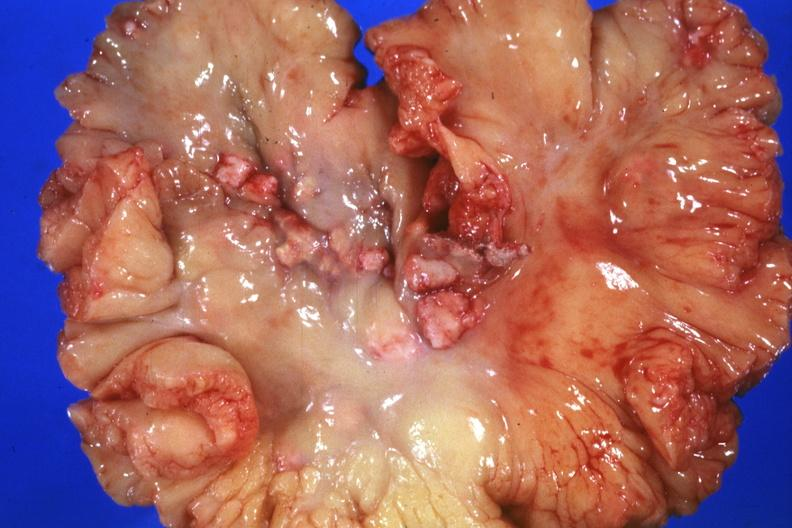s supernumerary digits present?
Answer the question using a single word or phrase. No 